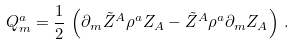<formula> <loc_0><loc_0><loc_500><loc_500>Q _ { m } ^ { a } = { \frac { 1 } { 2 } } \, \left ( \partial _ { m } \tilde { Z } ^ { A } \rho ^ { a } Z _ { A } - \tilde { Z } ^ { A } \rho ^ { a } \partial _ { m } Z _ { A } \right ) \, .</formula> 